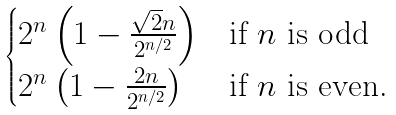Convert formula to latex. <formula><loc_0><loc_0><loc_500><loc_500>\begin{cases} 2 ^ { n } \left ( 1 - \frac { \sqrt { 2 } n } { 2 ^ { n / 2 } } \right ) & \text {if $n$ is odd} \\ 2 ^ { n } \left ( 1 - \frac { 2 n } { 2 ^ { n / 2 } } \right ) & \text {if $n$ is even.} \end{cases}</formula> 